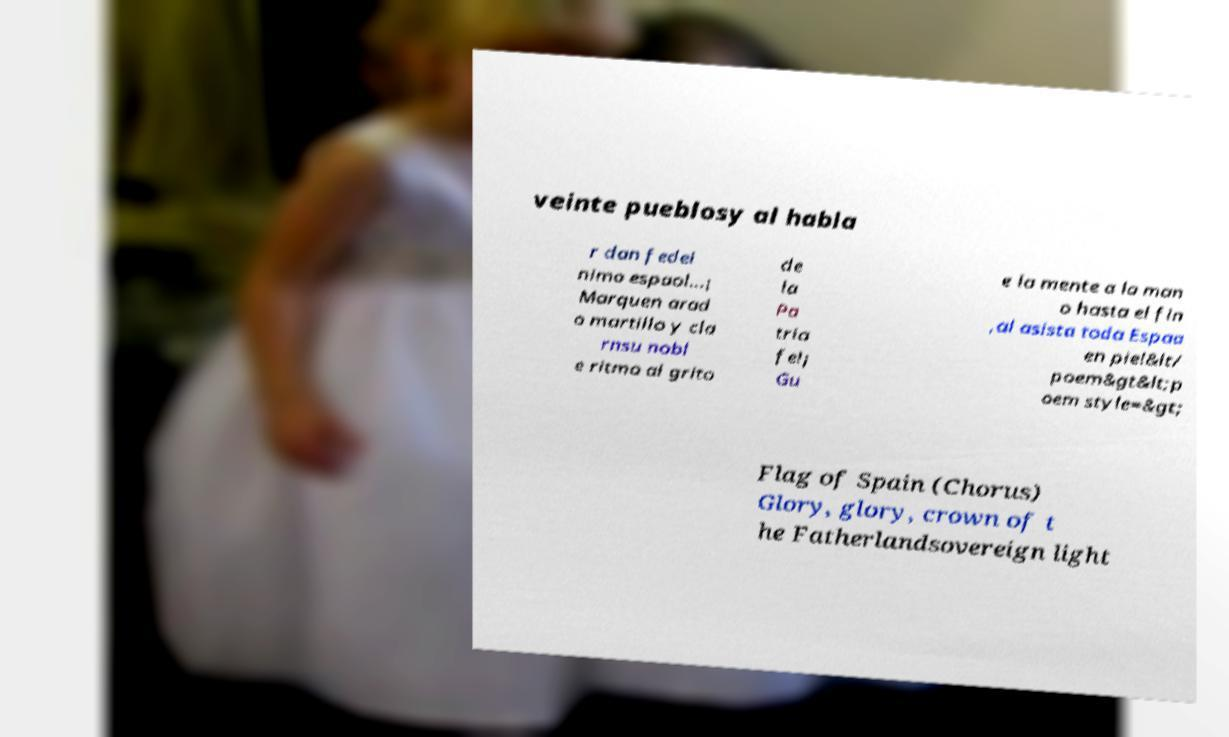For documentation purposes, I need the text within this image transcribed. Could you provide that? veinte pueblosy al habla r dan fedel nimo espaol...¡ Marquen arad o martillo y cla rnsu nobl e ritmo al grito de la Pa tria fe!¡ Gu e la mente a la man o hasta el fin ,al asista toda Espaa en pie!&lt/ poem&gt&lt;p oem style=&gt; Flag of Spain (Chorus) Glory, glory, crown of t he Fatherlandsovereign light 